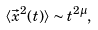Convert formula to latex. <formula><loc_0><loc_0><loc_500><loc_500>\langle \vec { x } ^ { 2 } ( t ) \rangle \sim t ^ { 2 \mu } ,</formula> 